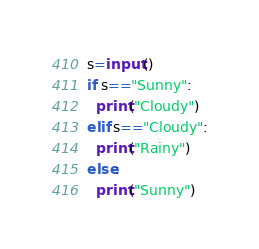<code> <loc_0><loc_0><loc_500><loc_500><_Python_>s=input()
if s=="Sunny":
  print("Cloudy")
elif s=="Cloudy":
  print("Rainy")
else:
  print("Sunny")

</code> 